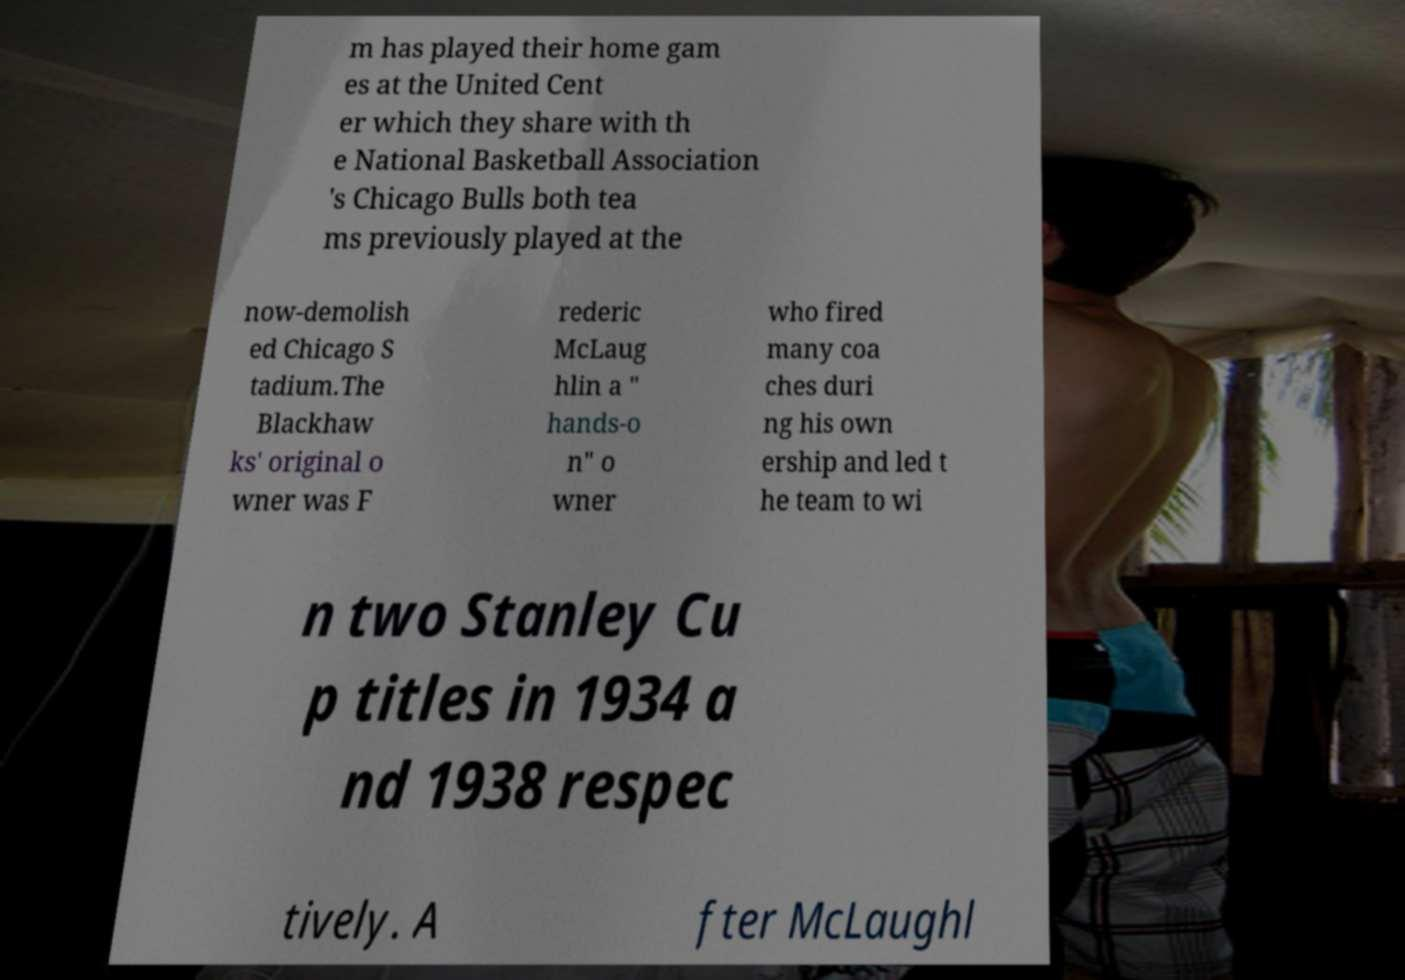What messages or text are displayed in this image? I need them in a readable, typed format. m has played their home gam es at the United Cent er which they share with th e National Basketball Association 's Chicago Bulls both tea ms previously played at the now-demolish ed Chicago S tadium.The Blackhaw ks' original o wner was F rederic McLaug hlin a " hands-o n" o wner who fired many coa ches duri ng his own ership and led t he team to wi n two Stanley Cu p titles in 1934 a nd 1938 respec tively. A fter McLaughl 